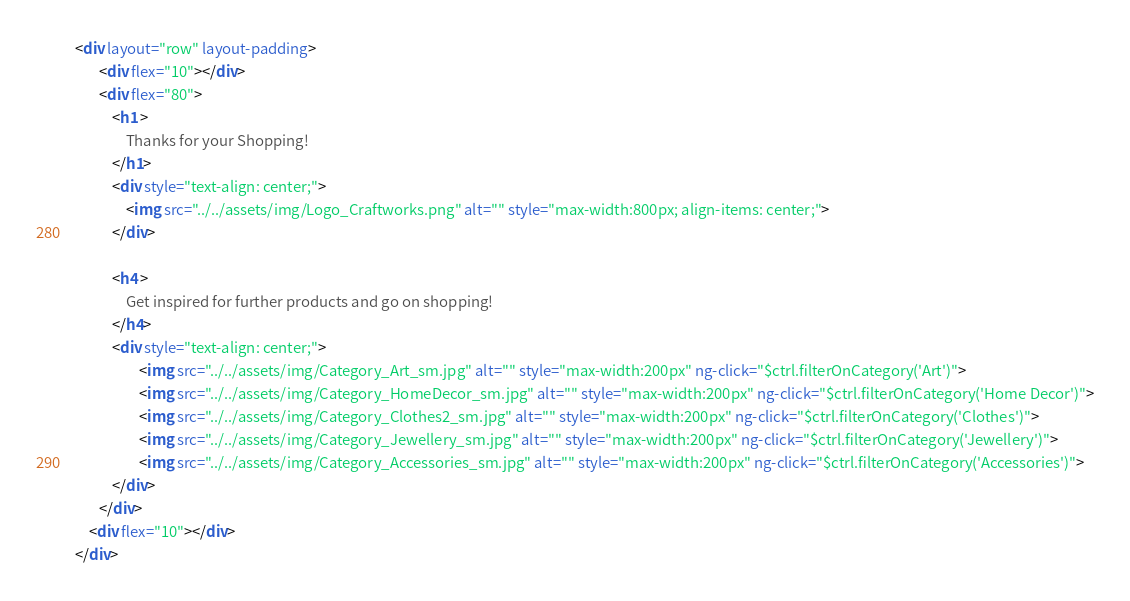Convert code to text. <code><loc_0><loc_0><loc_500><loc_500><_HTML_> <div layout="row" layout-padding>
        <div flex="10"></div>
        <div flex="80">
            <h1 >
                Thanks for your Shopping!
            </h1>
            <div style="text-align: center;">
                <img src="../../assets/img/Logo_Craftworks.png" alt="" style="max-width:800px; align-items: center;">
            </div>

            <h4 >
                Get inspired for further products and go on shopping!
            </h4>
            <div style="text-align: center;">
                    <img src="../../assets/img/Category_Art_sm.jpg" alt="" style="max-width:200px" ng-click="$ctrl.filterOnCategory('Art')">
                    <img src="../../assets/img/Category_HomeDecor_sm.jpg" alt="" style="max-width:200px" ng-click="$ctrl.filterOnCategory('Home Decor')">
                    <img src="../../assets/img/Category_Clothes2_sm.jpg" alt="" style="max-width:200px" ng-click="$ctrl.filterOnCategory('Clothes')">
                    <img src="../../assets/img/Category_Jewellery_sm.jpg" alt="" style="max-width:200px" ng-click="$ctrl.filterOnCategory('Jewellery')">
                    <img src="../../assets/img/Category_Accessories_sm.jpg" alt="" style="max-width:200px" ng-click="$ctrl.filterOnCategory('Accessories')">
            </div>
        </div>
     <div flex="10"></div>
 </div>


</code> 